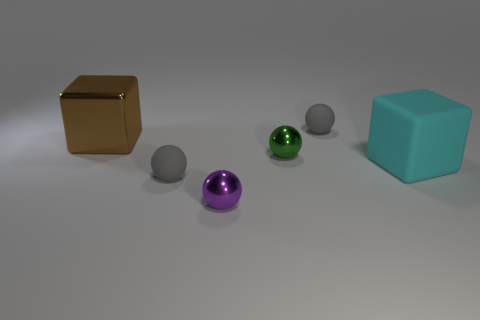There is a large cyan rubber block; are there any spheres in front of it?
Make the answer very short. Yes. How many spheres are either purple metallic objects or big red metallic objects?
Your answer should be compact. 1. Is the shape of the cyan matte object the same as the purple thing?
Provide a succinct answer. No. How big is the matte sphere that is to the right of the small green ball?
Offer a very short reply. Small. Is there a small rubber ball that has the same color as the large shiny block?
Give a very brief answer. No. There is a gray matte thing behind the brown object; does it have the same size as the large shiny object?
Offer a very short reply. No. What is the color of the big matte cube?
Give a very brief answer. Cyan. The rubber ball that is to the left of the metal ball behind the cyan rubber cube is what color?
Give a very brief answer. Gray. Are there any brown things that have the same material as the green object?
Make the answer very short. Yes. What material is the object to the left of the gray matte sphere that is in front of the big metallic thing?
Offer a very short reply. Metal. 